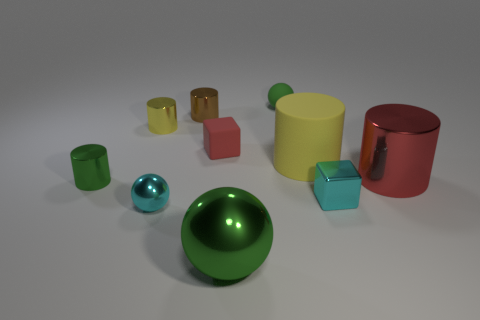What size is the metal thing that is the same color as the big matte object?
Provide a succinct answer. Small. Does the brown cylinder have the same material as the small green cylinder?
Offer a very short reply. Yes. What number of things are right of the tiny shiny cylinder in front of the red object behind the big red thing?
Provide a succinct answer. 9. How many cyan matte cylinders are there?
Provide a succinct answer. 0. Is the number of small cyan objects in front of the tiny cyan metal block less than the number of small shiny objects in front of the small yellow metallic cylinder?
Give a very brief answer. Yes. Are there fewer tiny brown objects that are in front of the big red metal object than large shiny cylinders?
Offer a very short reply. Yes. There is a green sphere behind the cylinder to the left of the yellow object that is left of the large green shiny thing; what is its material?
Provide a succinct answer. Rubber. What number of objects are metal objects that are behind the small green cylinder or tiny metal cylinders in front of the tiny brown shiny thing?
Your response must be concise. 4. There is another yellow thing that is the same shape as the tiny yellow thing; what is its material?
Give a very brief answer. Rubber. How many metal things are tiny red cubes or purple cylinders?
Your response must be concise. 0. 